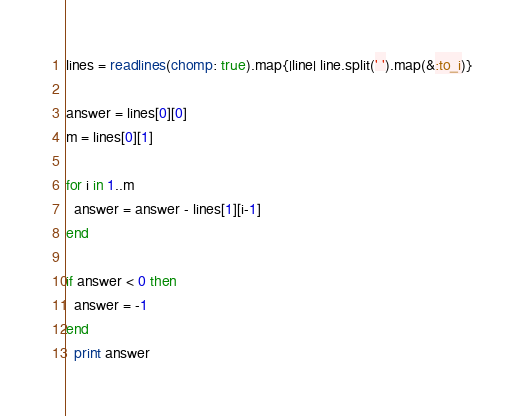<code> <loc_0><loc_0><loc_500><loc_500><_Ruby_>lines = readlines(chomp: true).map{|line| line.split(' ').map(&:to_i)}

answer = lines[0][0]
m = lines[0][1]

for i in 1..m
  answer = answer - lines[1][i-1]
end

if answer < 0 then
  answer = -1
end
  print answer</code> 